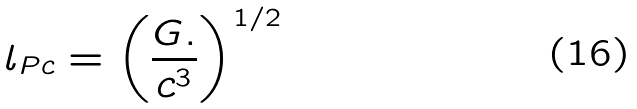<formula> <loc_0><loc_0><loc_500><loc_500>l _ { P c } = \left ( { \frac { G . } { { c ^ { 3 } } } } \right ) ^ { 1 / 2 }</formula> 